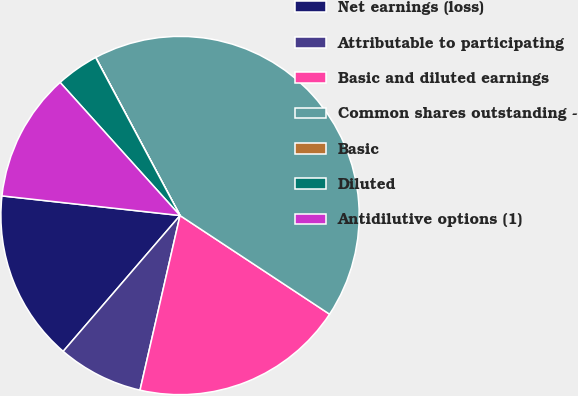<chart> <loc_0><loc_0><loc_500><loc_500><pie_chart><fcel>Net earnings (loss)<fcel>Attributable to participating<fcel>Basic and diluted earnings<fcel>Common shares outstanding -<fcel>Basic<fcel>Diluted<fcel>Antidilutive options (1)<nl><fcel>15.44%<fcel>7.72%<fcel>19.3%<fcel>42.08%<fcel>0.01%<fcel>3.86%<fcel>11.58%<nl></chart> 